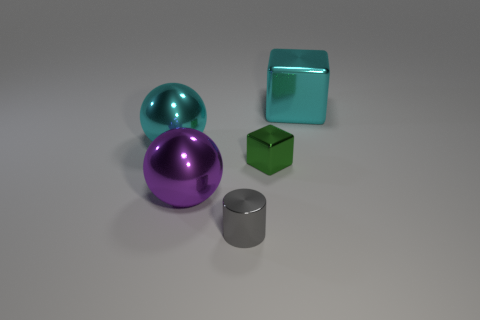Add 1 small blue metallic cylinders. How many objects exist? 6 Subtract all cylinders. How many objects are left? 4 Add 1 big metal balls. How many big metal balls exist? 3 Subtract 0 green cylinders. How many objects are left? 5 Subtract all purple shiny things. Subtract all large gray matte cylinders. How many objects are left? 4 Add 1 green things. How many green things are left? 2 